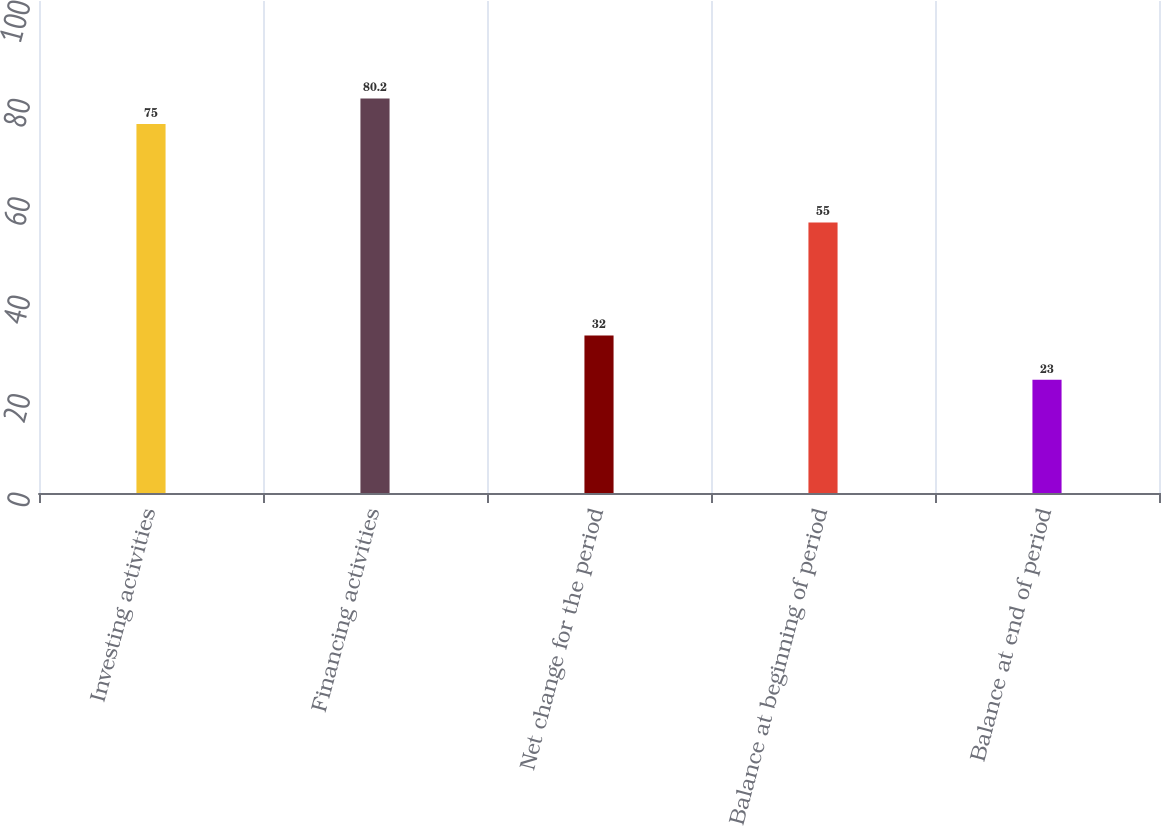Convert chart to OTSL. <chart><loc_0><loc_0><loc_500><loc_500><bar_chart><fcel>Investing activities<fcel>Financing activities<fcel>Net change for the period<fcel>Balance at beginning of period<fcel>Balance at end of period<nl><fcel>75<fcel>80.2<fcel>32<fcel>55<fcel>23<nl></chart> 